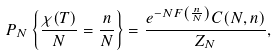Convert formula to latex. <formula><loc_0><loc_0><loc_500><loc_500>P _ { N } \left \{ \frac { \chi ( T ) } { N } = \frac { n } { N } \right \} = \frac { e ^ { - N F \left ( \frac { n } { N } \right ) } C ( N , n ) } { Z _ { N } } ,</formula> 